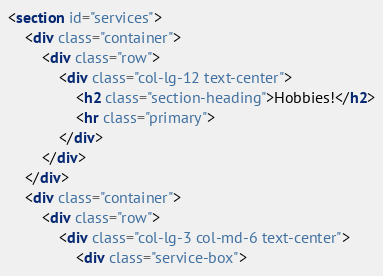Convert code to text. <code><loc_0><loc_0><loc_500><loc_500><_HTML_><section id="services">
    <div class="container">
        <div class="row">
            <div class="col-lg-12 text-center">
                <h2 class="section-heading">Hobbies!</h2>
                <hr class="primary">
            </div>
        </div>
    </div>
    <div class="container">
        <div class="row">
            <div class="col-lg-3 col-md-6 text-center">
                <div class="service-box"></code> 